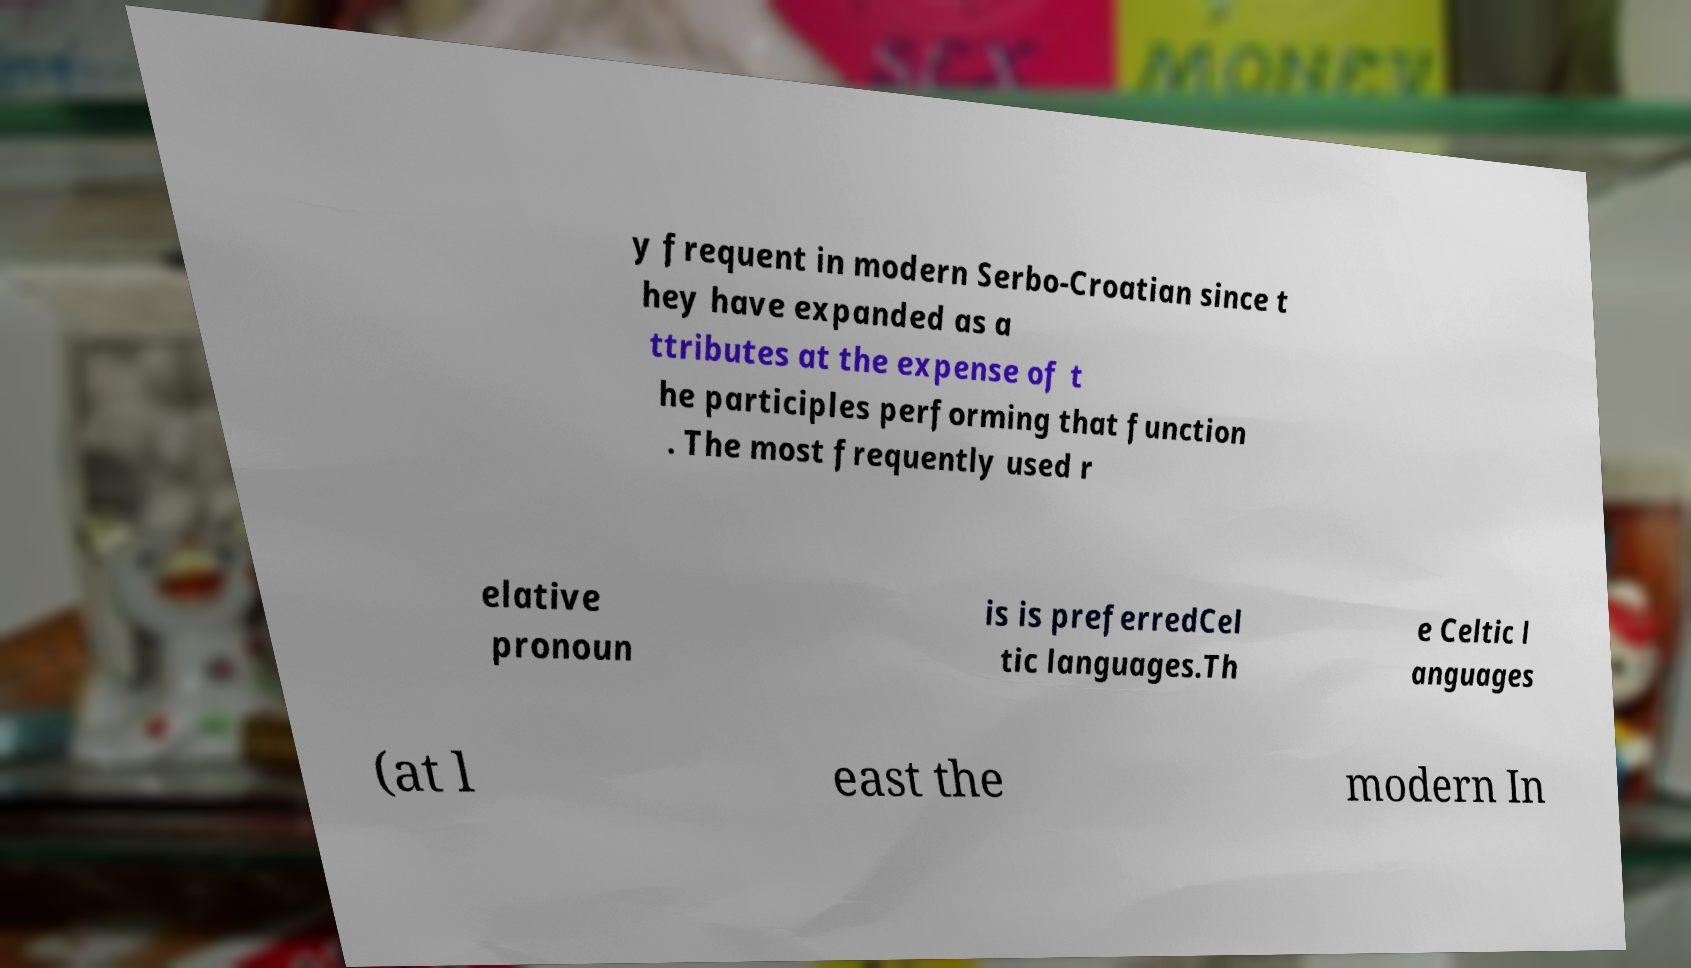I need the written content from this picture converted into text. Can you do that? y frequent in modern Serbo-Croatian since t hey have expanded as a ttributes at the expense of t he participles performing that function . The most frequently used r elative pronoun is is preferredCel tic languages.Th e Celtic l anguages (at l east the modern In 